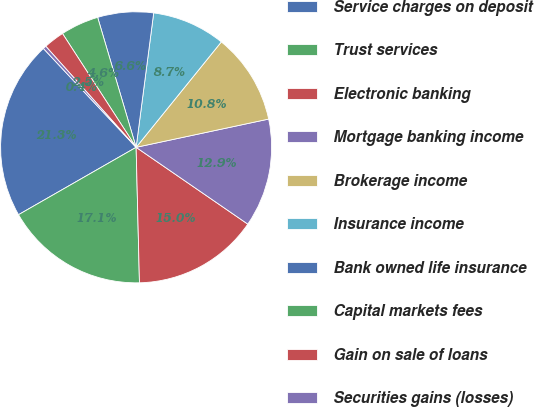Convert chart to OTSL. <chart><loc_0><loc_0><loc_500><loc_500><pie_chart><fcel>Service charges on deposit<fcel>Trust services<fcel>Electronic banking<fcel>Mortgage banking income<fcel>Brokerage income<fcel>Insurance income<fcel>Bank owned life insurance<fcel>Capital markets fees<fcel>Gain on sale of loans<fcel>Securities gains (losses)<nl><fcel>21.29%<fcel>17.11%<fcel>15.02%<fcel>12.93%<fcel>10.84%<fcel>8.75%<fcel>6.65%<fcel>4.56%<fcel>2.47%<fcel>0.38%<nl></chart> 